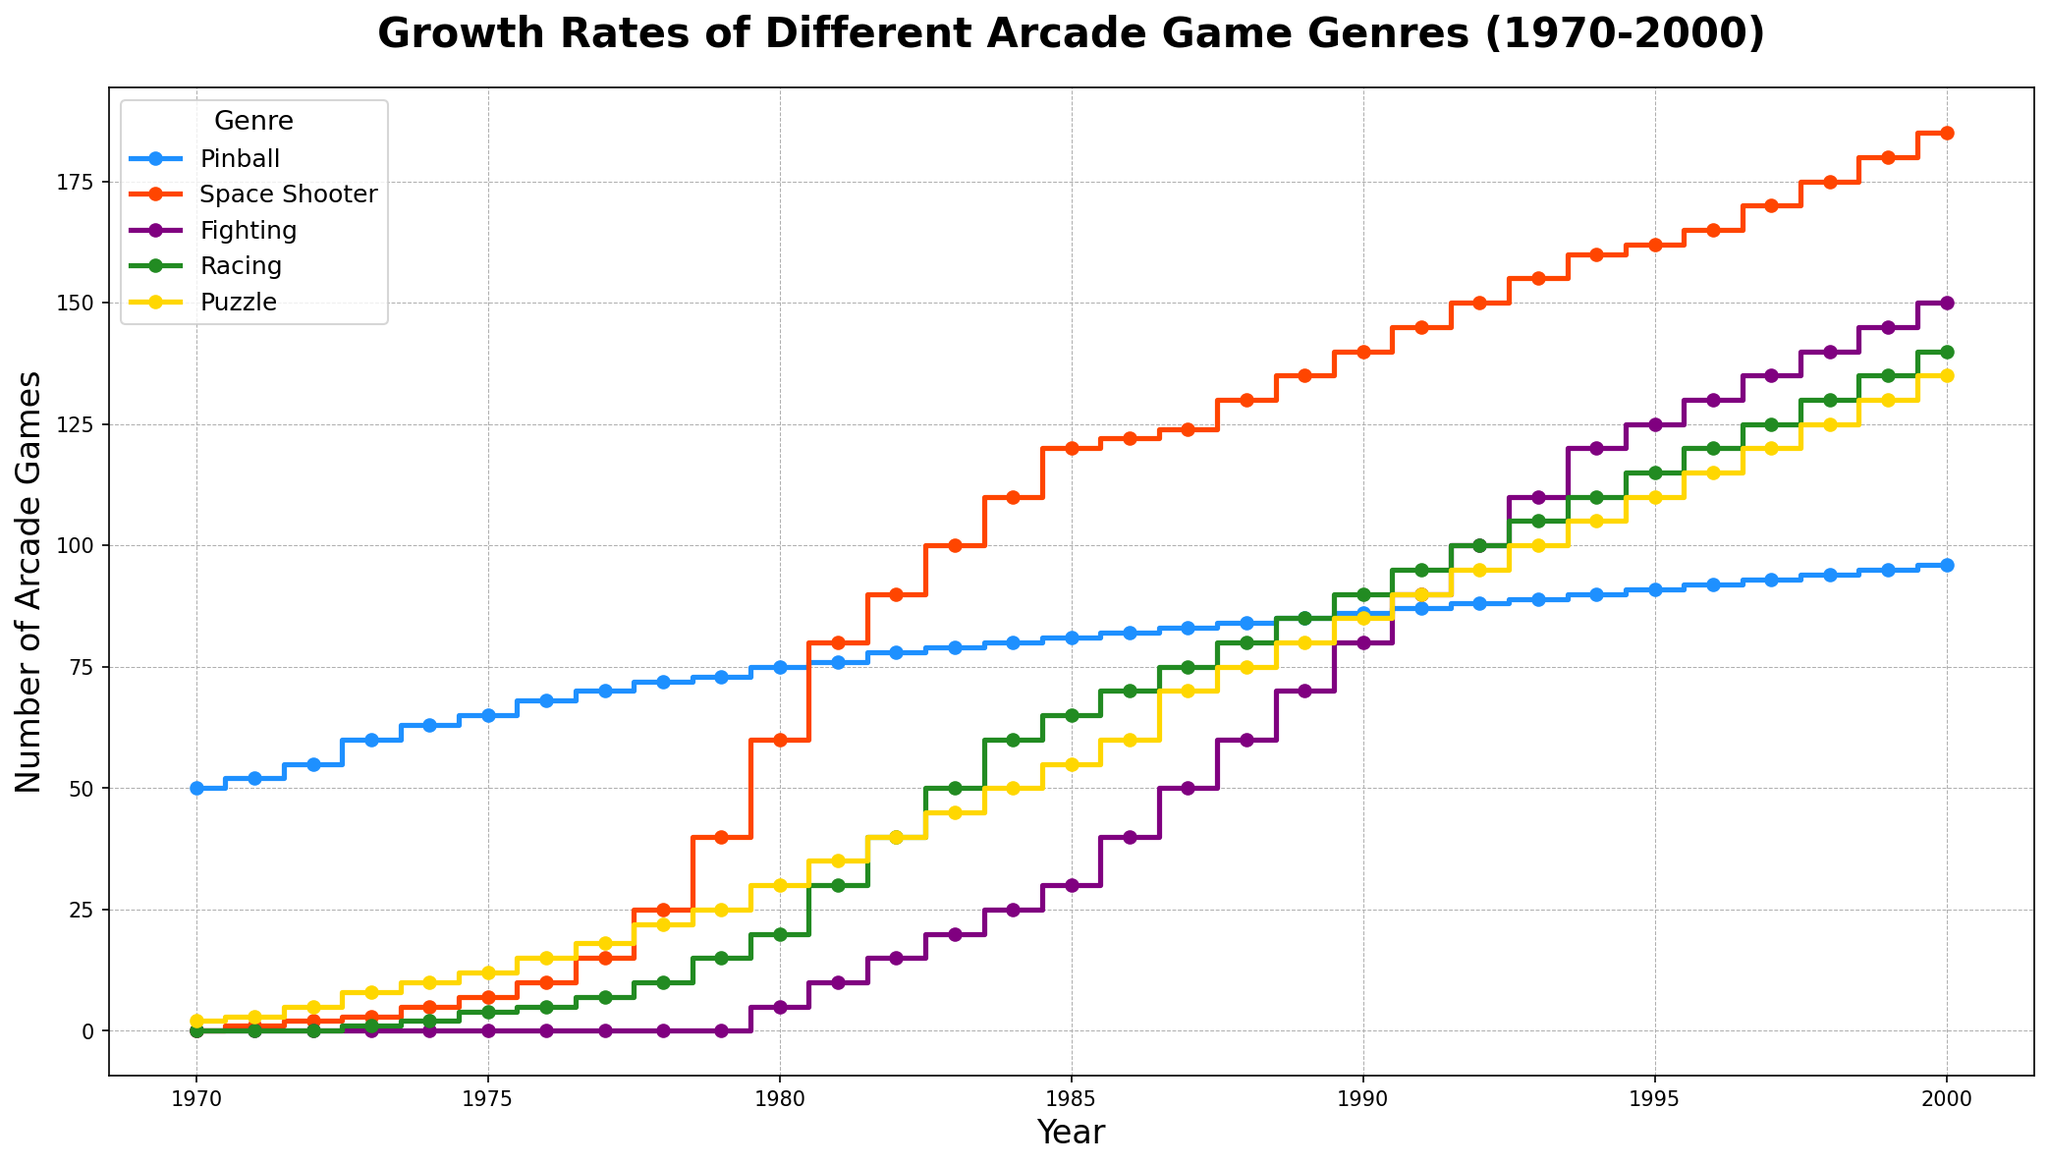Which genre had the fastest growth rate between 1970 and 1980? To determine the fastest growth rate between 1970 and 1980, observe the steepest increase in the number of arcade games for each genre. Space Shooter shows the most rapid increase, reaching 60 games by 1980.
Answer: Space Shooter How did the number of Pinball arcade games change from 1970 to 2000? Start by noting the initial value of Pinball games in 1970 and the final value in 2000. In 1970, there were 50 Pinball games, and by 2000, there were 96, representing an increase of 46 games over 30 years.
Answer: Increased by 46 Which genre had the largest number of arcade games by the year 2000? Compare the number of arcade games for each genre at the final year (2000). Space Shooter leads with 185 games by 2000.
Answer: Space Shooter Between 1980 and 1990, which genre saw the steepest increase in the number of arcade games? Check the growth for each genre from 1980 to 1990. Space Shooter had the largest increase from 60 to 140 games, adding 80 games over the decade.
Answer: Space Shooter What was the trend of Puzzle games from 1970 to 1980, and how did it change afterward? Observe the growth in Puzzle games from 1970 to 1980 and beyond. Initially, there is a steady growth from 2 to 30 games by 1980, followed by a continued but slightly slower increase, reaching 135 games by 2000.
Answer: Steady growth, slight slowdown afterward Compare the growth patterns of Racing and Fighting games between 1980 and 1990. Which grew faster? Look at the number of games for each genre in 1980 and 1990. Racing increases from 20 to 90 games (70 games), and Fighting increases from 5 to 80 games (75 games). Fighting grew slightly faster.
Answer: Fighting Which genre experienced the most consistent growth from 1970 to 2000? To identify consistent growth, look for a steady, linear increase without sharp fluctuations. Pinball shows the most uniform growth, increasing gradually each year from 50 to 96 games.
Answer: Pinball During which decade did Puzzle games see the highest increase? Calculate the increase for each decade and compare. From 1980 to 1990, Puzzle games increased from 30 to 85, adding 55 games, which is the highest among all decades.
Answer: 1980 to 1990 In 1985, how many more Fighting arcade games were there compared to Pinball games? Check the number of Fighting and Pinball games in 1985. Fighting had 30 games, and Pinball had 81 games, so Fighting had 51 fewer games.
Answer: 51 fewer games What were the comparative trends in the growth of Space Shooter and Puzzle games in the 1990s? Look at how each genre grew from 1990 to 2000. Space Shooter increased from 140 to 185 (45 games), and Puzzle grew from 85 to 135 (50 games), making Puzzle's growth slightly higher.
Answer: Puzzle 